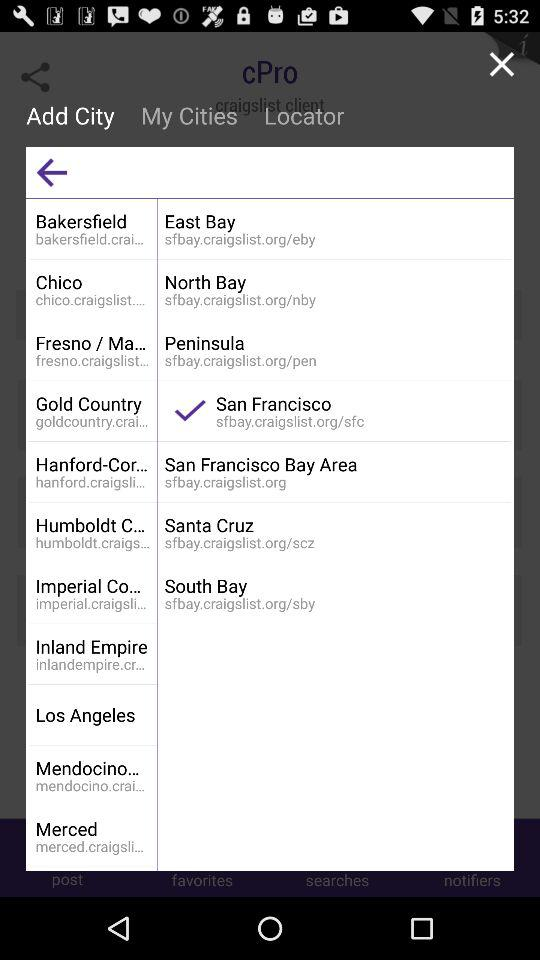What is the web address of the selected city? The web address of the selected city is sfbay.craigslist.org/sfc. 